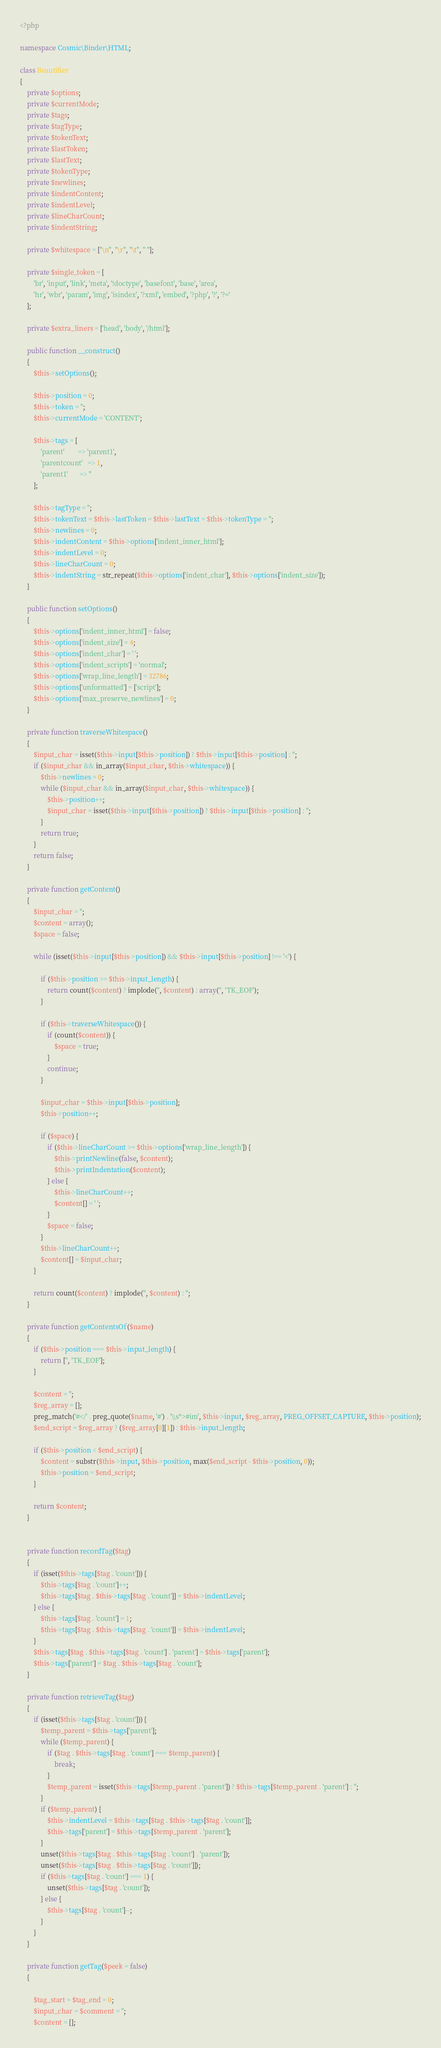Convert code to text. <code><loc_0><loc_0><loc_500><loc_500><_PHP_><?php

namespace Cosmic\Binder\HTML;

class Beautifier
{
    private $options;
    private $currentMode;
    private $tags;
    private $tagType;
    private $tokenText;
    private $lastToken;
    private $lastText;
    private $tokenType;
    private $newlines;
    private $indentContent;
    private $indentLevel;
    private $lineCharCount;
    private $indentString;

    private $whitespace = ["\n", "\r", "\t", " "];

    private $single_token = [
        'br', 'input', 'link', 'meta', '!doctype', 'basefont', 'base', 'area',
        'hr', 'wbr', 'param', 'img', 'isindex', '?xml', 'embed', '?php', '?', '?='
    ];

    private $extra_liners = ['head', 'body', '/html'];

    public function __construct()
    {
        $this->setOptions();

        $this->position = 0;
        $this->token = '';
        $this->currentMode = 'CONTENT';

        $this->tags = [
            'parent'        => 'parent1',
            'parentcount'   => 1,
            'parent1'       => ''
        ];

        $this->tagType = '';
        $this->tokenText = $this->lastToken = $this->lastText = $this->tokenType = '';
        $this->newlines = 0;
        $this->indentContent = $this->options['indent_inner_html'];
        $this->indentLevel = 0;
        $this->lineCharCount = 0;
        $this->indentString = str_repeat($this->options['indent_char'], $this->options['indent_size']);
    }

    public function setOptions()
    {
        $this->options['indent_inner_html'] = false;
        $this->options['indent_size'] = 4;
        $this->options['indent_char'] = ' ';
        $this->options['indent_scripts'] = 'normal';
        $this->options['wrap_line_length'] = 32786;
        $this->options['unformatted'] = ['script'];
        $this->options['max_preserve_newlines'] = 0;
    }

    private function traverseWhitespace()
    {
        $input_char = isset($this->input[$this->position]) ? $this->input[$this->position] : '';
        if ($input_char && in_array($input_char, $this->whitespace)) {
            $this->newlines = 0;
            while ($input_char && in_array($input_char, $this->whitespace)) {
                $this->position++;
                $input_char = isset($this->input[$this->position]) ? $this->input[$this->position] : '';
            }
            return true;
        }
        return false;
    }

    private function getContent()
    {
        $input_char = '';
        $content = array();
        $space = false;

        while (isset($this->input[$this->position]) && $this->input[$this->position] !== '<') {

            if ($this->position >= $this->input_length) {
                return count($content) ? implode('', $content) : array('', 'TK_EOF');
            }

            if ($this->traverseWhitespace()) {
                if (count($content)) {
                    $space = true;
                }
                continue;
            }

            $input_char = $this->input[$this->position];
            $this->position++;

            if ($space) {
                if ($this->lineCharCount >= $this->options['wrap_line_length']) {
                    $this->printNewline(false, $content);
                    $this->printIndentation($content);
                } else {
                    $this->lineCharCount++;
                    $content[] = ' ';
                }
                $space = false;
            }
            $this->lineCharCount++;
            $content[] = $input_char;
        }

        return count($content) ? implode('', $content) : '';
    }

    private function getContentsOf($name)
    {
        if ($this->position === $this->input_length) {
            return ['', 'TK_EOF'];
        }

        $content = '';
        $reg_array = [];
        preg_match('#</' . preg_quote($name, '#') . '\\s*>#im', $this->input, $reg_array, PREG_OFFSET_CAPTURE, $this->position);
        $end_script = $reg_array ? ($reg_array[0][1]) : $this->input_length;

        if ($this->position < $end_script) {
            $content = substr($this->input, $this->position, max($end_script - $this->position, 0));
            $this->position = $end_script;
        }

        return $content;
    }


    private function recordTag($tag)
    {
        if (isset($this->tags[$tag . 'count'])) {
            $this->tags[$tag . 'count']++;
            $this->tags[$tag . $this->tags[$tag . 'count']] = $this->indentLevel;
        } else {
            $this->tags[$tag . 'count'] = 1;
            $this->tags[$tag . $this->tags[$tag . 'count']] = $this->indentLevel;
        }
        $this->tags[$tag . $this->tags[$tag . 'count'] . 'parent'] = $this->tags['parent'];
        $this->tags['parent'] = $tag . $this->tags[$tag . 'count'];
    }

    private function retrieveTag($tag)
    {
        if (isset($this->tags[$tag . 'count'])) {
            $temp_parent = $this->tags['parent'];
            while ($temp_parent) {
                if ($tag . $this->tags[$tag . 'count'] === $temp_parent) {
                    break;
                }
                $temp_parent = isset($this->tags[$temp_parent . 'parent']) ? $this->tags[$temp_parent . 'parent'] : '';
            }
            if ($temp_parent) {
                $this->indentLevel = $this->tags[$tag . $this->tags[$tag . 'count']];
                $this->tags['parent'] = $this->tags[$temp_parent . 'parent'];
            }
            unset($this->tags[$tag . $this->tags[$tag . 'count'] . 'parent']);
            unset($this->tags[$tag . $this->tags[$tag . 'count']]);
            if ($this->tags[$tag . 'count'] === 1) {
                unset($this->tags[$tag . 'count']);
            } else {
                $this->tags[$tag . 'count']--;
            }
        }
    }

    private function getTag($peek = false)
    {

        $tag_start = $tag_end = 0;
        $input_char = $comment = '';
        $content = [];</code> 